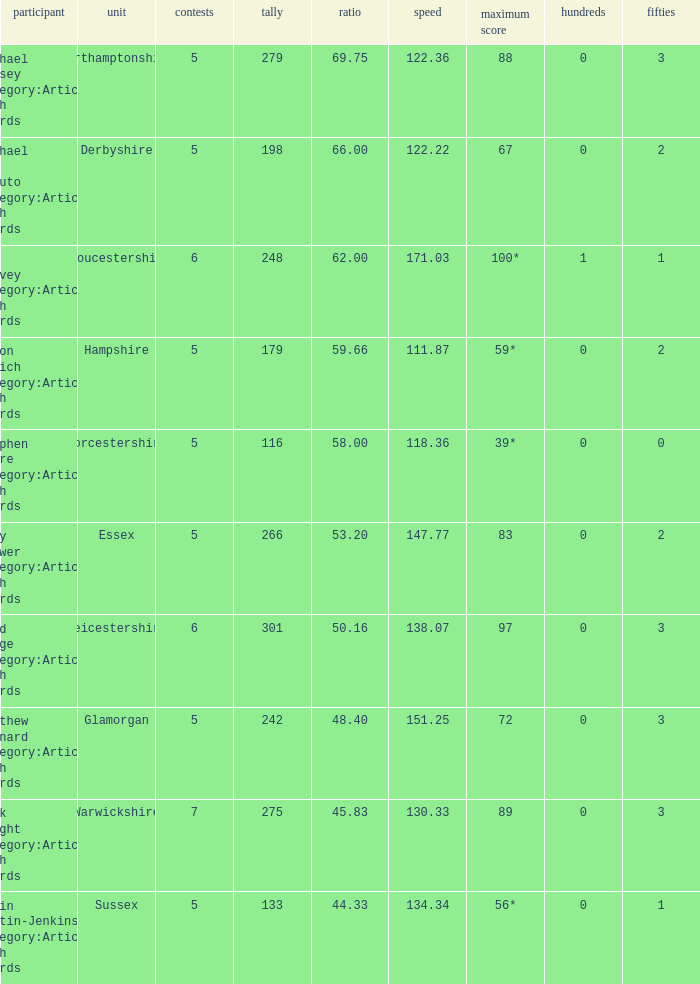If the average is 50.16, who is the player? Brad Hodge Category:Articles with hCards. 